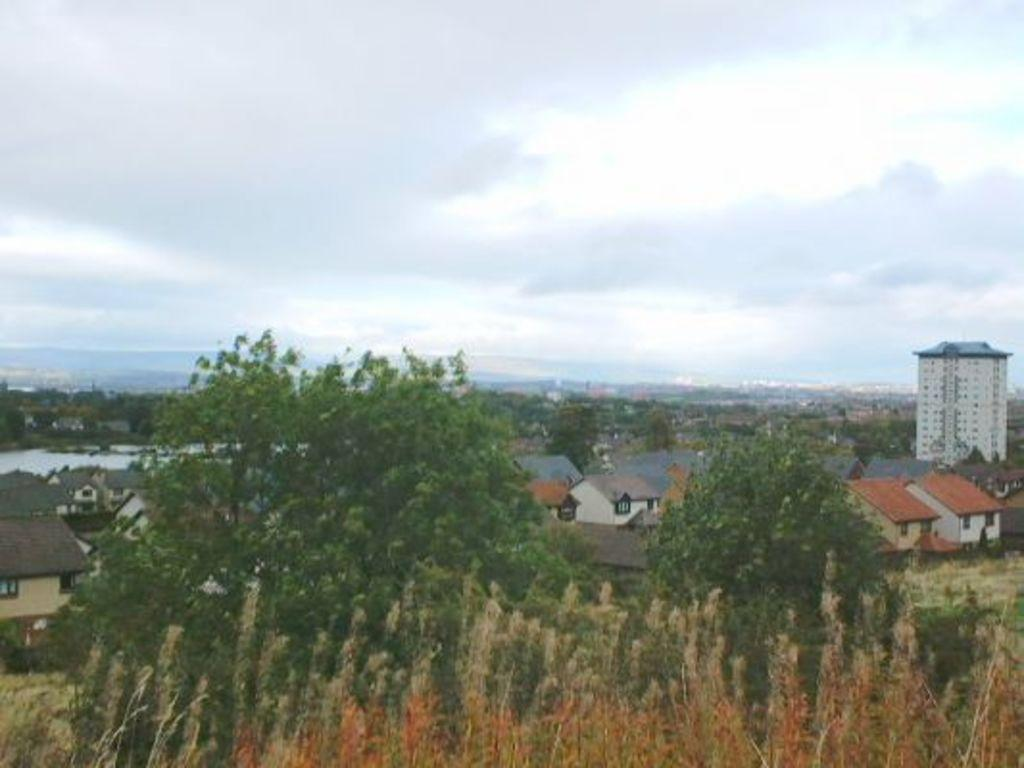What type of vegetation is present in the front of the image? There are trees and bushes in the front of the image. What type of structures can be seen in the background of the image? There are buildings in the background of the image. What else can be seen in the background of the image besides buildings? There are trees and clouds visible in the background of the image. What part of the natural environment is visible in the background of the image? The sky is visible in the background of the image. How many hands are visible in the image? There are no hands visible in the image. Can you describe the sisters in the image? There are no sisters present in the image. What type of creature is shown interacting with the trees in the image? There is no creature shown interacting with the trees in the image; only trees, bushes, buildings, and clouds are present. 